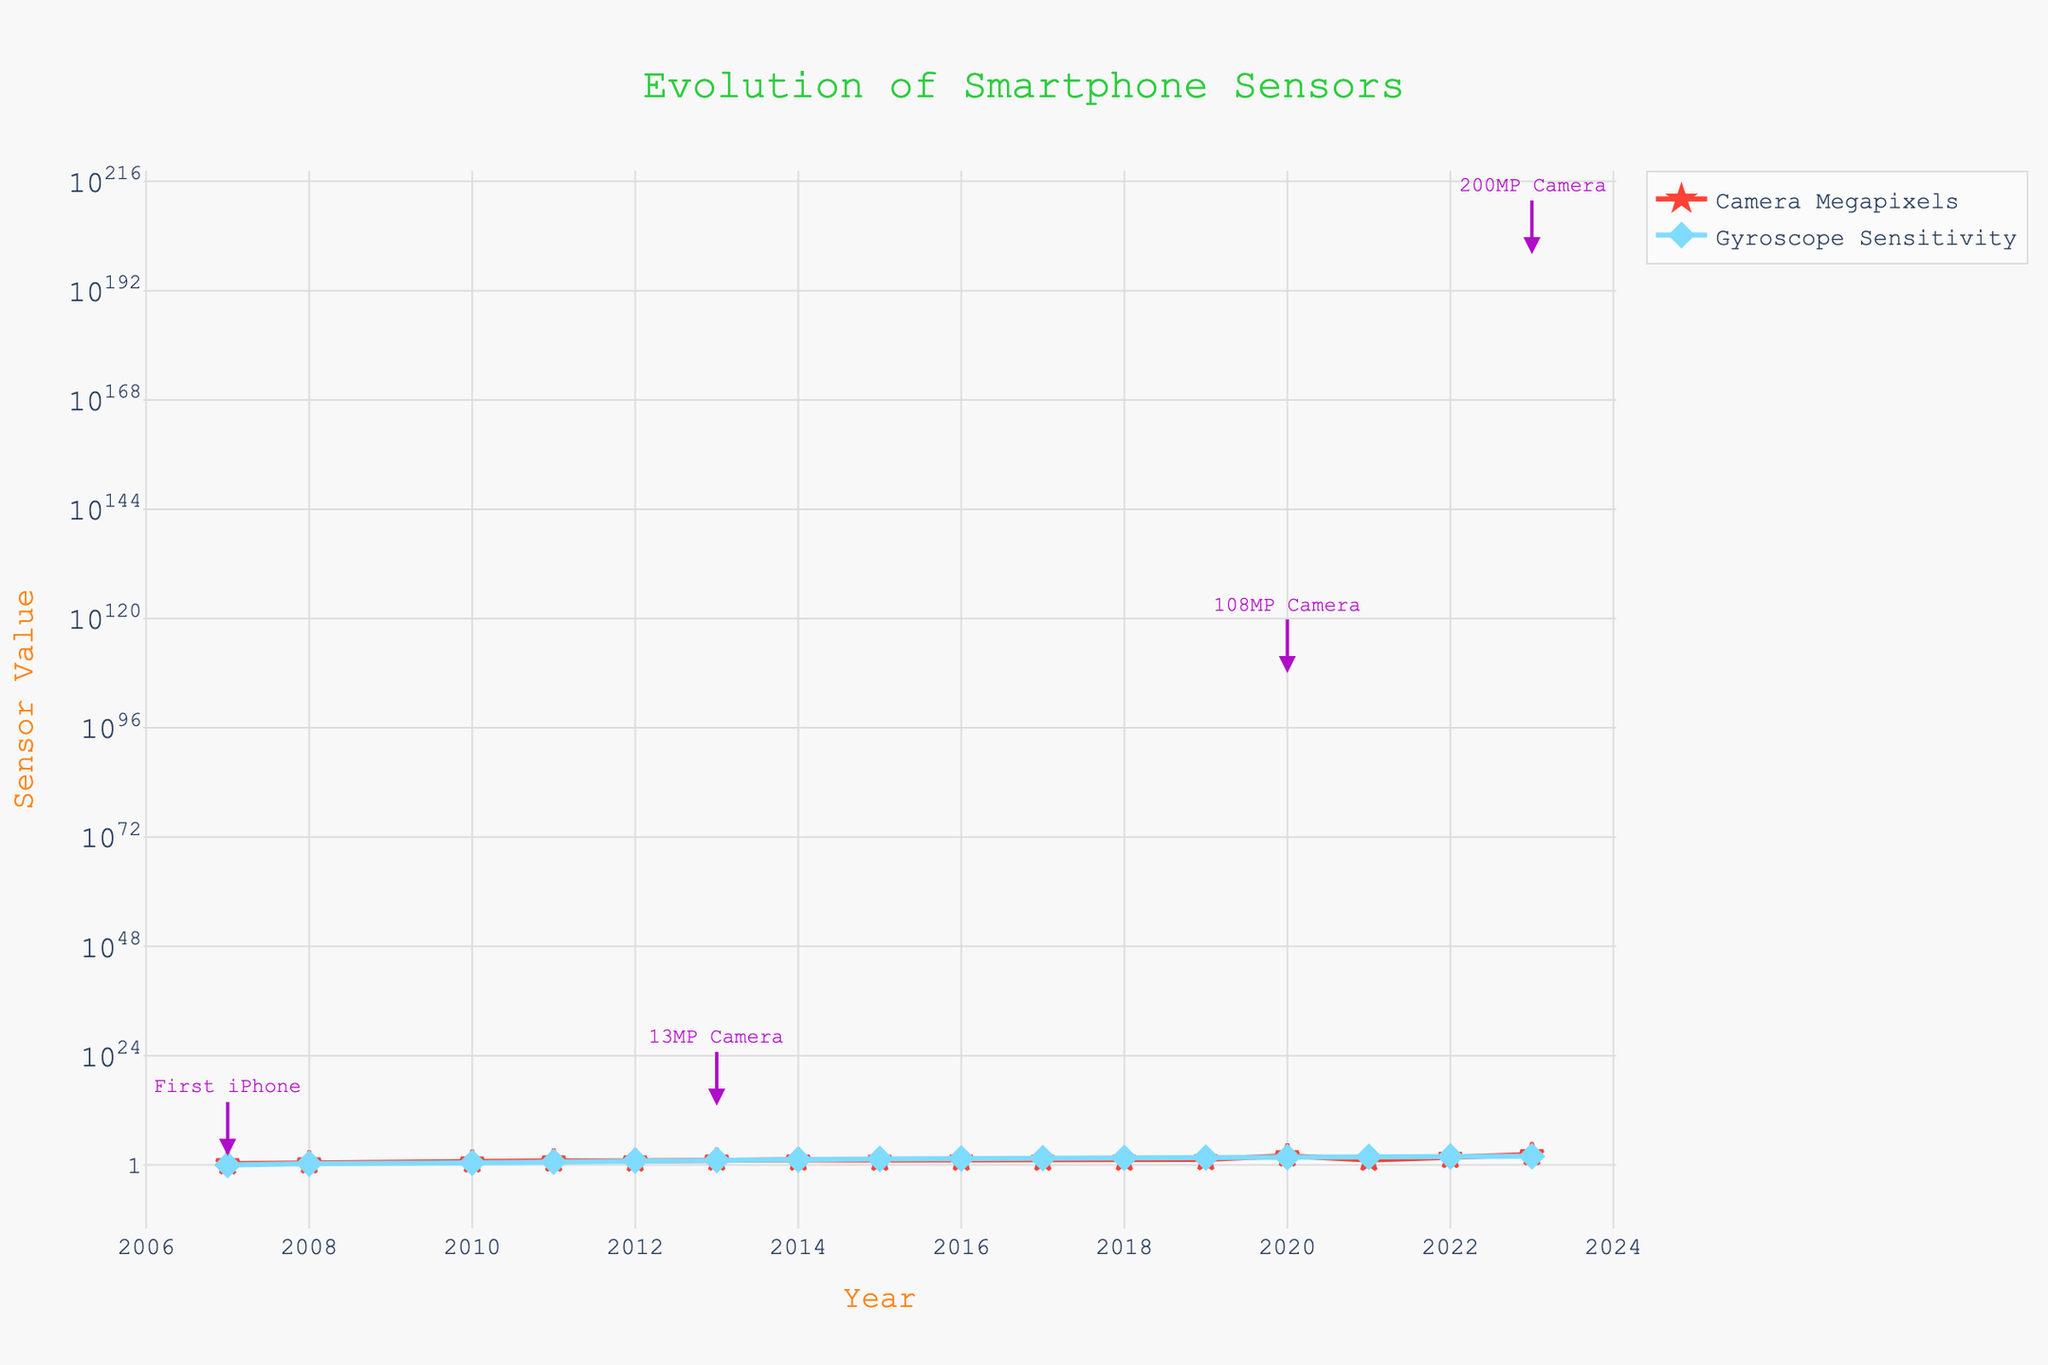How many data points are there in the plot? The x-axis represents the year, and each year's entry represents a data point. Counting the unique years from 2007 to 2023 gives us 17 data points.
Answer: 17 What is the title of the plot? The title is located at the top center of the plot. It reads 'Evolution of Smartphone Sensors'.
Answer: Evolution of Smartphone Sensors Which year saw the first smartphone with a gyroscope sensitivity of above 10? To find the first year where the gyroscope sensitivity exceeds 10, locate the values on the y-axis for the blue "Gyroscope Sensitivity" line. The year 2013 (Samsung Galaxy S4) has a gyroscope sensitivity of 12.
Answer: 2013 How many smartphone models between 2007 and 2023 have camera megapixels less than 10? Observe the red "Camera Megapixels" line and identify the years where camera megapixels are below 10. These models are from years 2007 (iPhone 2G), 2008 (HTC Dream), 2010 (Samsung Galaxy S), and 2011 (Motorola Droid Bionic). Thus, there are 4 such models.
Answer: 4 By how much did the gyroscope sensitivity increase from the iPhone 2G (2007) to the Samsung Galaxy S23 Ultra (2023)? The gyroscope sensitivity for the iPhone 2G in 2007 was 1, and for the Samsung Galaxy S23 Ultra in 2023, it was 80. The increase is 80 - 1 = 79.
Answer: 79 Which device had the first 108MP camera, and in which year was it released? Follow the red "Camera Megapixels" line to locate the plot point for 108MP, which is in the year 2020. The corresponding device is the Samsung Galaxy S20 Ultra.
Answer: Samsung Galaxy S20 Ultra, 2020 How does the camera megapixels of the Google Pixel 6 Pro compare to that of the iPhone 13 Pro Max? Find the values for both devices on the red "Camera Megapixels" line. The Google Pixel 6 Pro (2022) has 50MP, while the iPhone 13 Pro Max (2021) has 12MP. Therefore, the Google Pixel 6 Pro has a higher camera resolution.
Answer: Google Pixel 6 Pro has higher megapixels What do the colors red and blue lines represent in the plot? The legend in the plot clarifies that the red line represents "Camera Megapixels" and the blue line represents "Gyroscope Sensitivity".
Answer: Camera Megapixels and Gyroscope Sensitivity Which year had the smallest increment in camera megapixels from the previous year, and what was the increment? Inspect the red "Camera Megapixels" line over the years. The smallest increment is between 2015 (12MP) and 2016 (12.3MP), and the increment is 12.3 - 12 = 0.3MP.
Answer: 2016, 0.3MP What trend do you observe in both camera megapixels and gyroscope sensitivity over the years? Both metrics generally show an upward trend over the years, signifying continuous improvement and enhancement in smartphone sensor technology. Camera megapixels see steeper jumps compared to more steady increases in gyroscope sensitivity.
Answer: Upward trend 